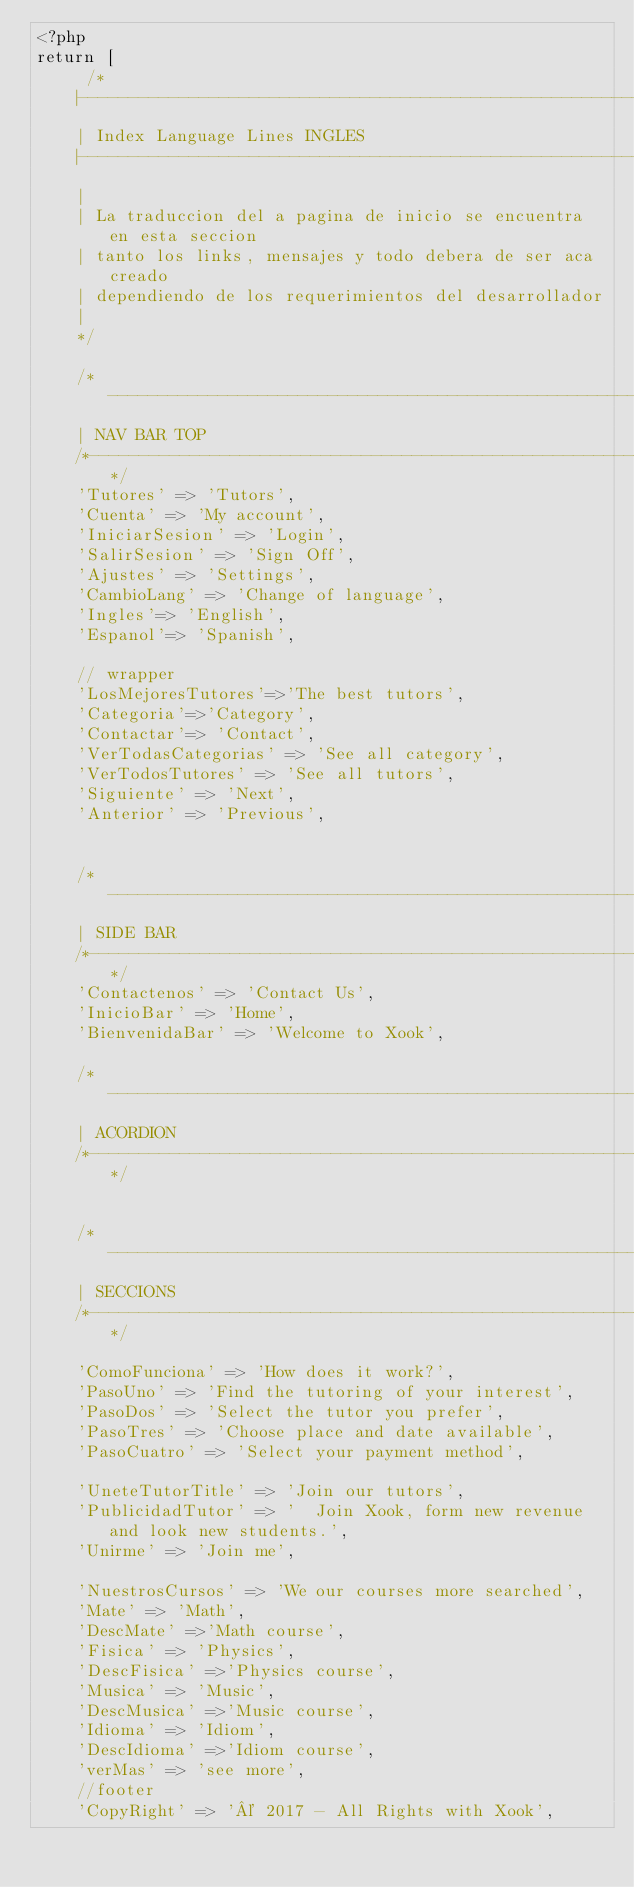<code> <loc_0><loc_0><loc_500><loc_500><_PHP_><?php
return [
     /*
    |--------------------------------------------------------------------------
    | Index Language Lines INGLES
    |--------------------------------------------------------------------------
    |
    | La traduccion del a pagina de inicio se encuentra en esta seccion
    | tanto los links, mensajes y todo debera de ser aca creado 
    | dependiendo de los requerimientos del desarrollador
    |
    */
 
    /*-------------------------------------------------------
    | NAV BAR TOP
    /*-------------------------------------------------------*/
    'Tutores' => 'Tutors',
    'Cuenta' => 'My account',
    'IniciarSesion' => 'Login',
    'SalirSesion' => 'Sign Off',    
    'Ajustes' => 'Settings',
    'CambioLang' => 'Change of language',
    'Ingles'=> 'English',
    'Espanol'=> 'Spanish',    
    
    // wrapper
    'LosMejoresTutores'=>'The best tutors',
    'Categoria'=>'Category',
    'Contactar'=> 'Contact',
    'VerTodasCategorias' => 'See all category',
    'VerTodosTutores' => 'See all tutors',
    'Siguiente' => 'Next',
    'Anterior' => 'Previous',
    
    
    /*-------------------------------------------------------
    | SIDE BAR
    /*-------------------------------------------------------*/
    'Contactenos' => 'Contact Us',
    'InicioBar' => 'Home',
    'BienvenidaBar' => 'Welcome to Xook',
    
    /*-------------------------------------------------------
    | ACORDION
    /*-------------------------------------------------------*/
    
    
    /*-------------------------------------------------------
    | SECCIONS
    /*-------------------------------------------------------*/
    
    'ComoFunciona' => 'How does it work?',
    'PasoUno' => 'Find the tutoring of your interest',
    'PasoDos' => 'Select the tutor you prefer',
    'PasoTres' => 'Choose place and date available',
    'PasoCuatro' => 'Select your payment method',
    
    'UneteTutorTitle' => 'Join our tutors',
    'PublicidadTutor' => '  Join Xook, form new revenue and look new students.',
    'Unirme' => 'Join me',
    
    'NuestrosCursos' => 'We our courses more searched',
    'Mate' => 'Math',
    'DescMate' =>'Math course',
    'Fisica' => 'Physics',
    'DescFisica' =>'Physics course',
    'Musica' => 'Music',
    'DescMusica' =>'Music course',
    'Idioma' => 'Idiom',
    'DescIdioma' =>'Idiom course',
    'verMas' => 'see more',
    //footer
    'CopyRight' => '© 2017 - All Rights with Xook',</code> 